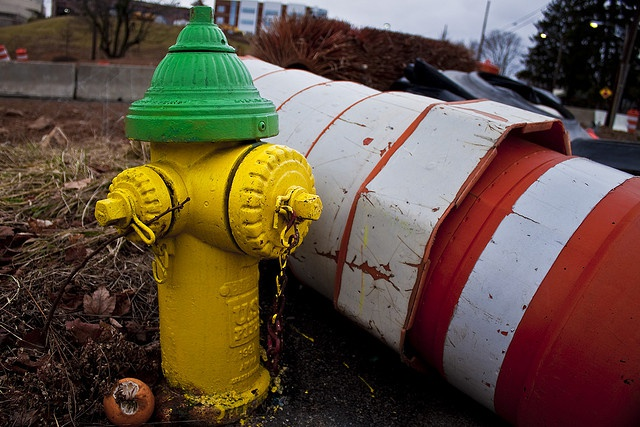Describe the objects in this image and their specific colors. I can see a fire hydrant in gray, olive, black, and gold tones in this image. 